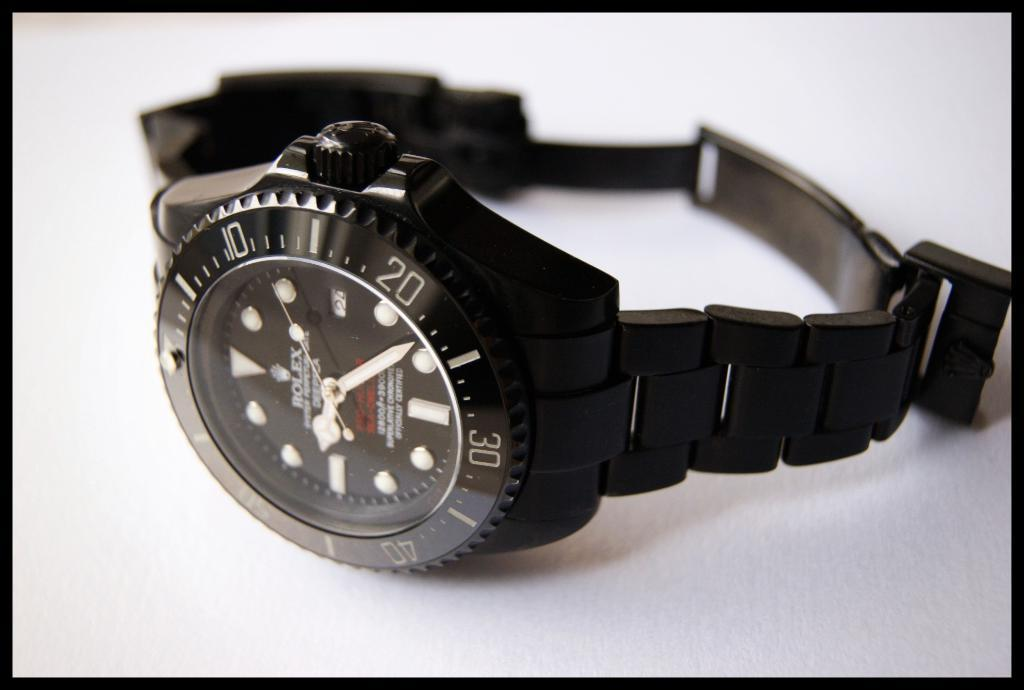<image>
Write a terse but informative summary of the picture. a black Rolex watch is laying on its side on the table 